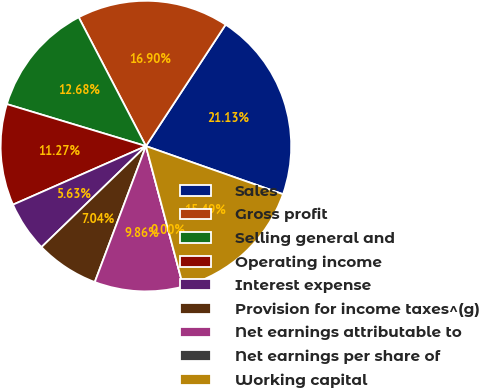Convert chart to OTSL. <chart><loc_0><loc_0><loc_500><loc_500><pie_chart><fcel>Sales<fcel>Gross profit<fcel>Selling general and<fcel>Operating income<fcel>Interest expense<fcel>Provision for income taxes^(g)<fcel>Net earnings attributable to<fcel>Net earnings per share of<fcel>Working capital<nl><fcel>21.13%<fcel>16.9%<fcel>12.68%<fcel>11.27%<fcel>5.63%<fcel>7.04%<fcel>9.86%<fcel>0.0%<fcel>15.49%<nl></chart> 